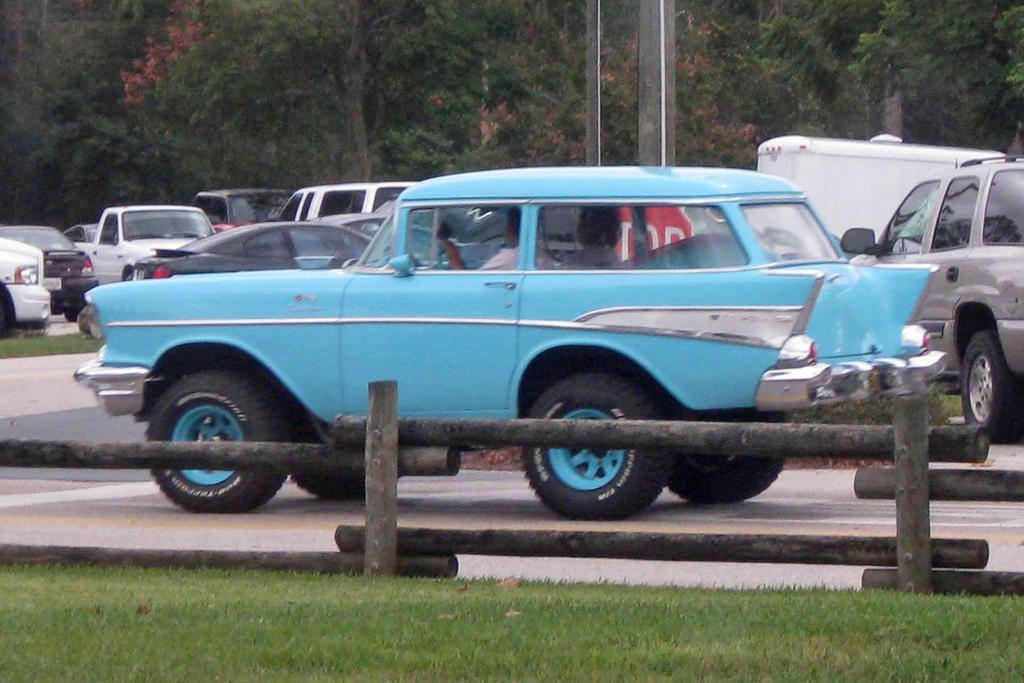What can be seen on the road in the image? There are cars on the road in the image. What is located at the bottom of the image? There is a fence and grassy land at the bottom of the image. What is visible at the top of the image? There are trees and poles at the top of the image. Can you see any snails crawling on the poles in the image? There are no snails present in the image; only cars, a fence, grassy land, trees, and poles can be seen. What type of comb is used to style the trees in the image? There is no comb present in the image, and the trees are not styled. 